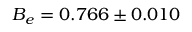<formula> <loc_0><loc_0><loc_500><loc_500>B _ { e } = { 0 . 7 6 6 \pm 0 . 0 1 0 }</formula> 